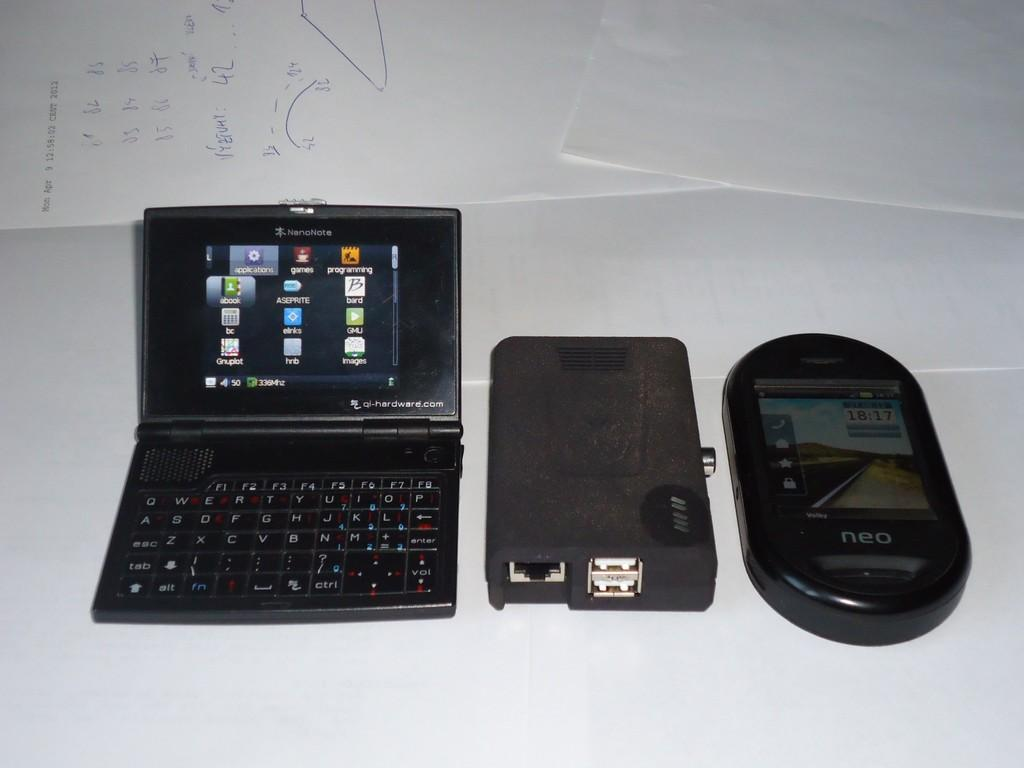<image>
Offer a succinct explanation of the picture presented. A Nanonote device sits next to other components on a white surface. 